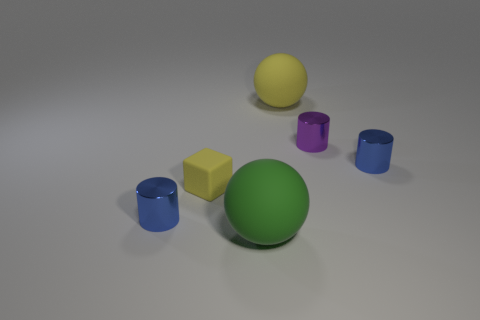Add 1 big blue spheres. How many objects exist? 7 Subtract all purple shiny cylinders. How many cylinders are left? 2 Subtract all spheres. How many objects are left? 4 Subtract all blue cylinders. Subtract all tiny shiny things. How many objects are left? 1 Add 1 small yellow things. How many small yellow things are left? 2 Add 4 green rubber things. How many green rubber things exist? 5 Subtract 0 red cubes. How many objects are left? 6 